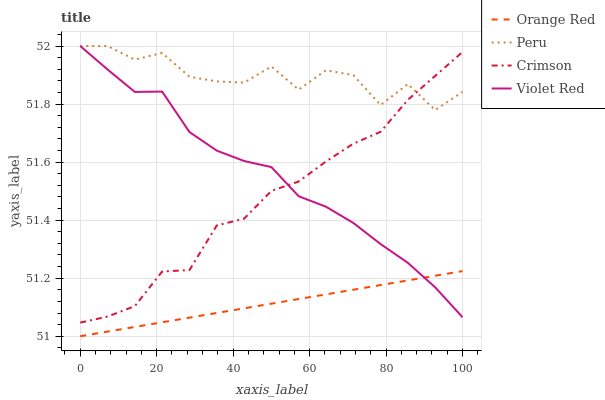Does Orange Red have the minimum area under the curve?
Answer yes or no. Yes. Does Peru have the maximum area under the curve?
Answer yes or no. Yes. Does Violet Red have the minimum area under the curve?
Answer yes or no. No. Does Violet Red have the maximum area under the curve?
Answer yes or no. No. Is Orange Red the smoothest?
Answer yes or no. Yes. Is Peru the roughest?
Answer yes or no. Yes. Is Violet Red the smoothest?
Answer yes or no. No. Is Violet Red the roughest?
Answer yes or no. No. Does Orange Red have the lowest value?
Answer yes or no. Yes. Does Violet Red have the lowest value?
Answer yes or no. No. Does Peru have the highest value?
Answer yes or no. Yes. Does Orange Red have the highest value?
Answer yes or no. No. Is Orange Red less than Peru?
Answer yes or no. Yes. Is Peru greater than Orange Red?
Answer yes or no. Yes. Does Peru intersect Violet Red?
Answer yes or no. Yes. Is Peru less than Violet Red?
Answer yes or no. No. Is Peru greater than Violet Red?
Answer yes or no. No. Does Orange Red intersect Peru?
Answer yes or no. No. 